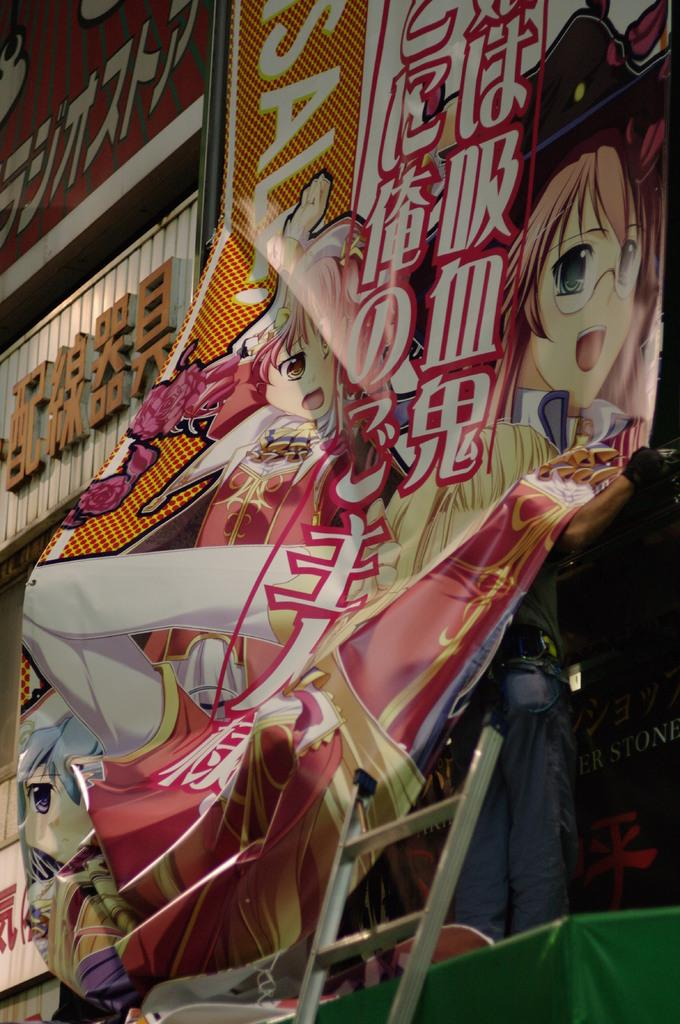What type of signage is present in the image? There are banners and name boards in the image. What can be found on the banners and name boards? Something is written on the banners and name boards. What other elements can be seen in the image? There are animated characters in the image. What might be used to reach a higher position in the image? There is a ladder at the bottom of the image. What type of cream is being used to paint the animated characters in the image? There is no cream being used to paint the animated characters in the image; they are likely digital or drawn. 